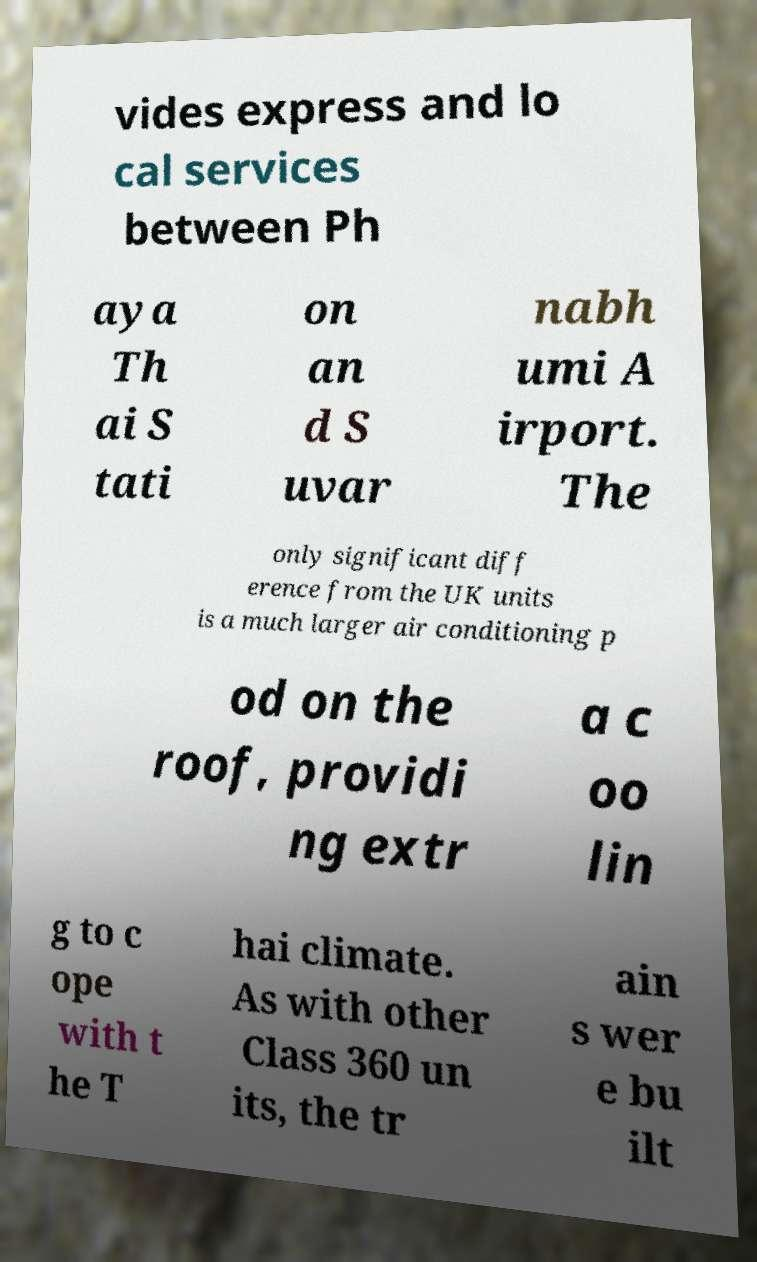Can you read and provide the text displayed in the image?This photo seems to have some interesting text. Can you extract and type it out for me? vides express and lo cal services between Ph aya Th ai S tati on an d S uvar nabh umi A irport. The only significant diff erence from the UK units is a much larger air conditioning p od on the roof, providi ng extr a c oo lin g to c ope with t he T hai climate. As with other Class 360 un its, the tr ain s wer e bu ilt 